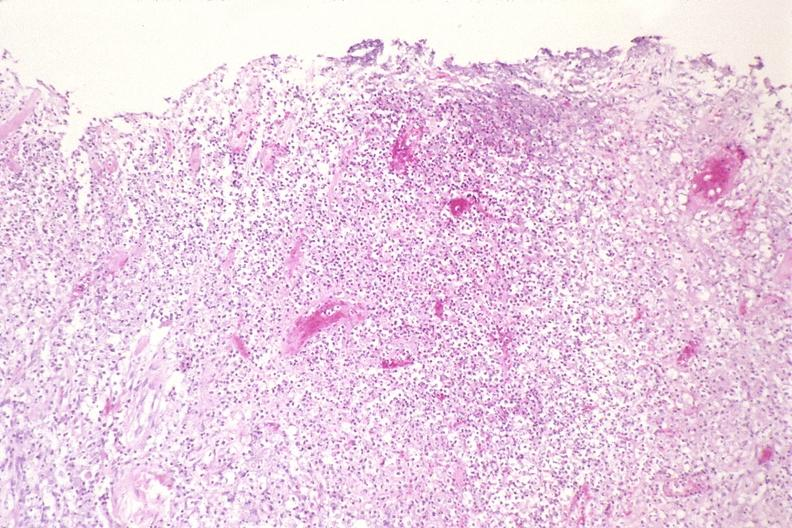where is this?
Answer the question using a single word or phrase. Lung 